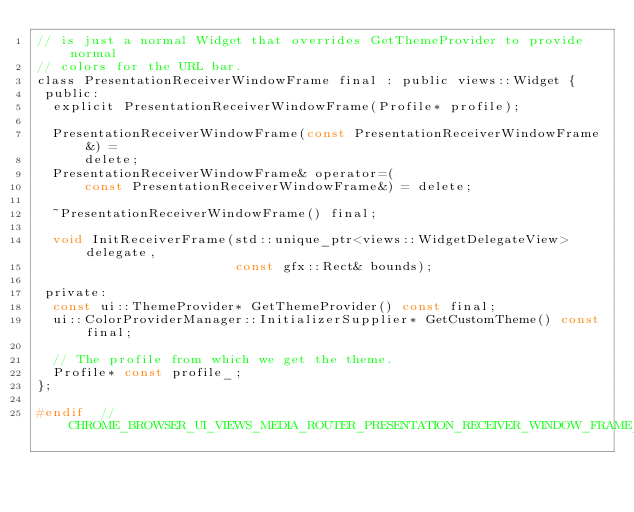Convert code to text. <code><loc_0><loc_0><loc_500><loc_500><_C_>// is just a normal Widget that overrides GetThemeProvider to provide normal
// colors for the URL bar.
class PresentationReceiverWindowFrame final : public views::Widget {
 public:
  explicit PresentationReceiverWindowFrame(Profile* profile);

  PresentationReceiverWindowFrame(const PresentationReceiverWindowFrame&) =
      delete;
  PresentationReceiverWindowFrame& operator=(
      const PresentationReceiverWindowFrame&) = delete;

  ~PresentationReceiverWindowFrame() final;

  void InitReceiverFrame(std::unique_ptr<views::WidgetDelegateView> delegate,
                         const gfx::Rect& bounds);

 private:
  const ui::ThemeProvider* GetThemeProvider() const final;
  ui::ColorProviderManager::InitializerSupplier* GetCustomTheme() const final;

  // The profile from which we get the theme.
  Profile* const profile_;
};

#endif  // CHROME_BROWSER_UI_VIEWS_MEDIA_ROUTER_PRESENTATION_RECEIVER_WINDOW_FRAME_H_
</code> 